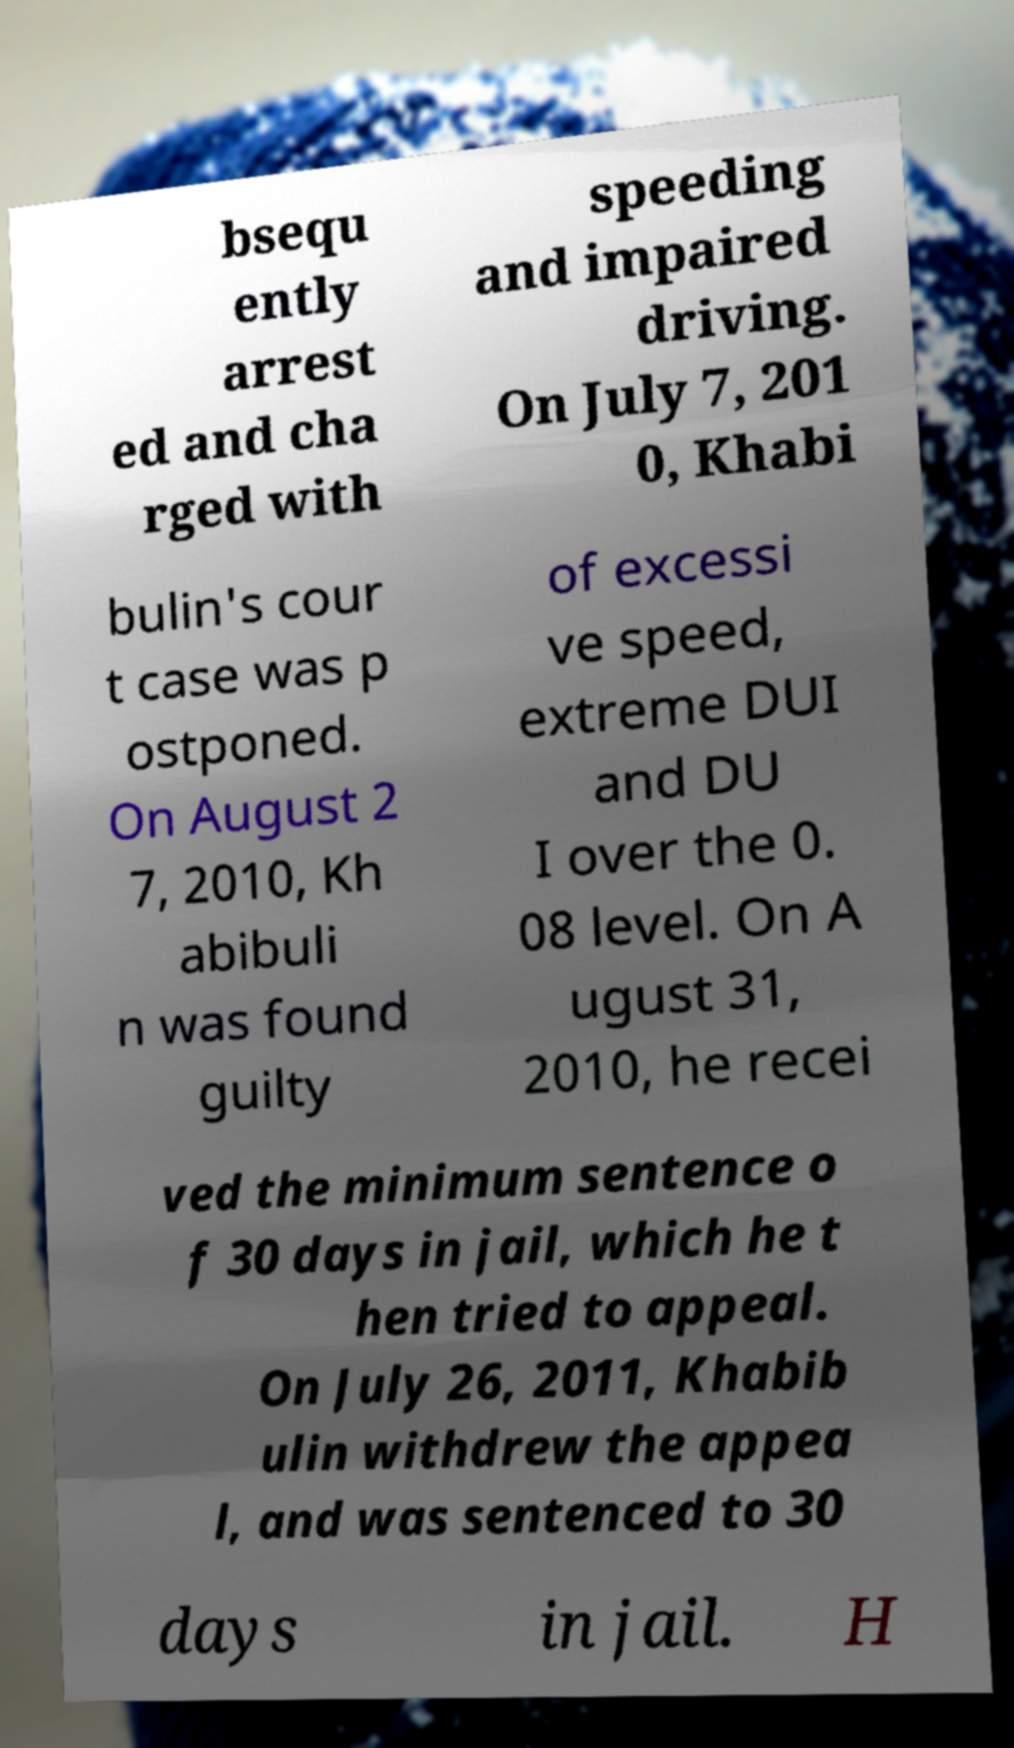Could you extract and type out the text from this image? bsequ ently arrest ed and cha rged with speeding and impaired driving. On July 7, 201 0, Khabi bulin's cour t case was p ostponed. On August 2 7, 2010, Kh abibuli n was found guilty of excessi ve speed, extreme DUI and DU I over the 0. 08 level. On A ugust 31, 2010, he recei ved the minimum sentence o f 30 days in jail, which he t hen tried to appeal. On July 26, 2011, Khabib ulin withdrew the appea l, and was sentenced to 30 days in jail. H 